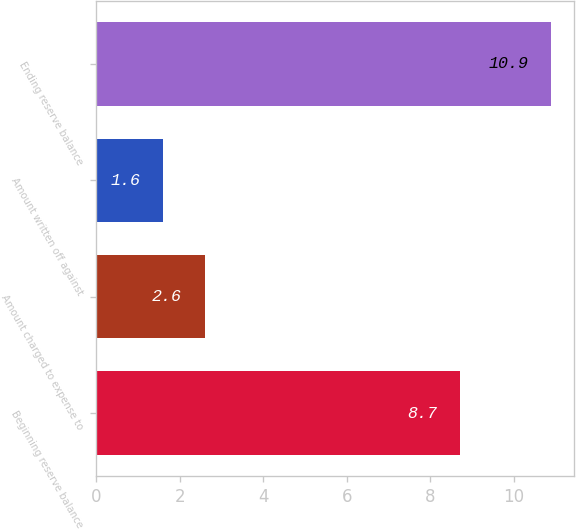<chart> <loc_0><loc_0><loc_500><loc_500><bar_chart><fcel>Beginning reserve balance<fcel>Amount charged to expense to<fcel>Amount written off against<fcel>Ending reserve balance<nl><fcel>8.7<fcel>2.6<fcel>1.6<fcel>10.9<nl></chart> 